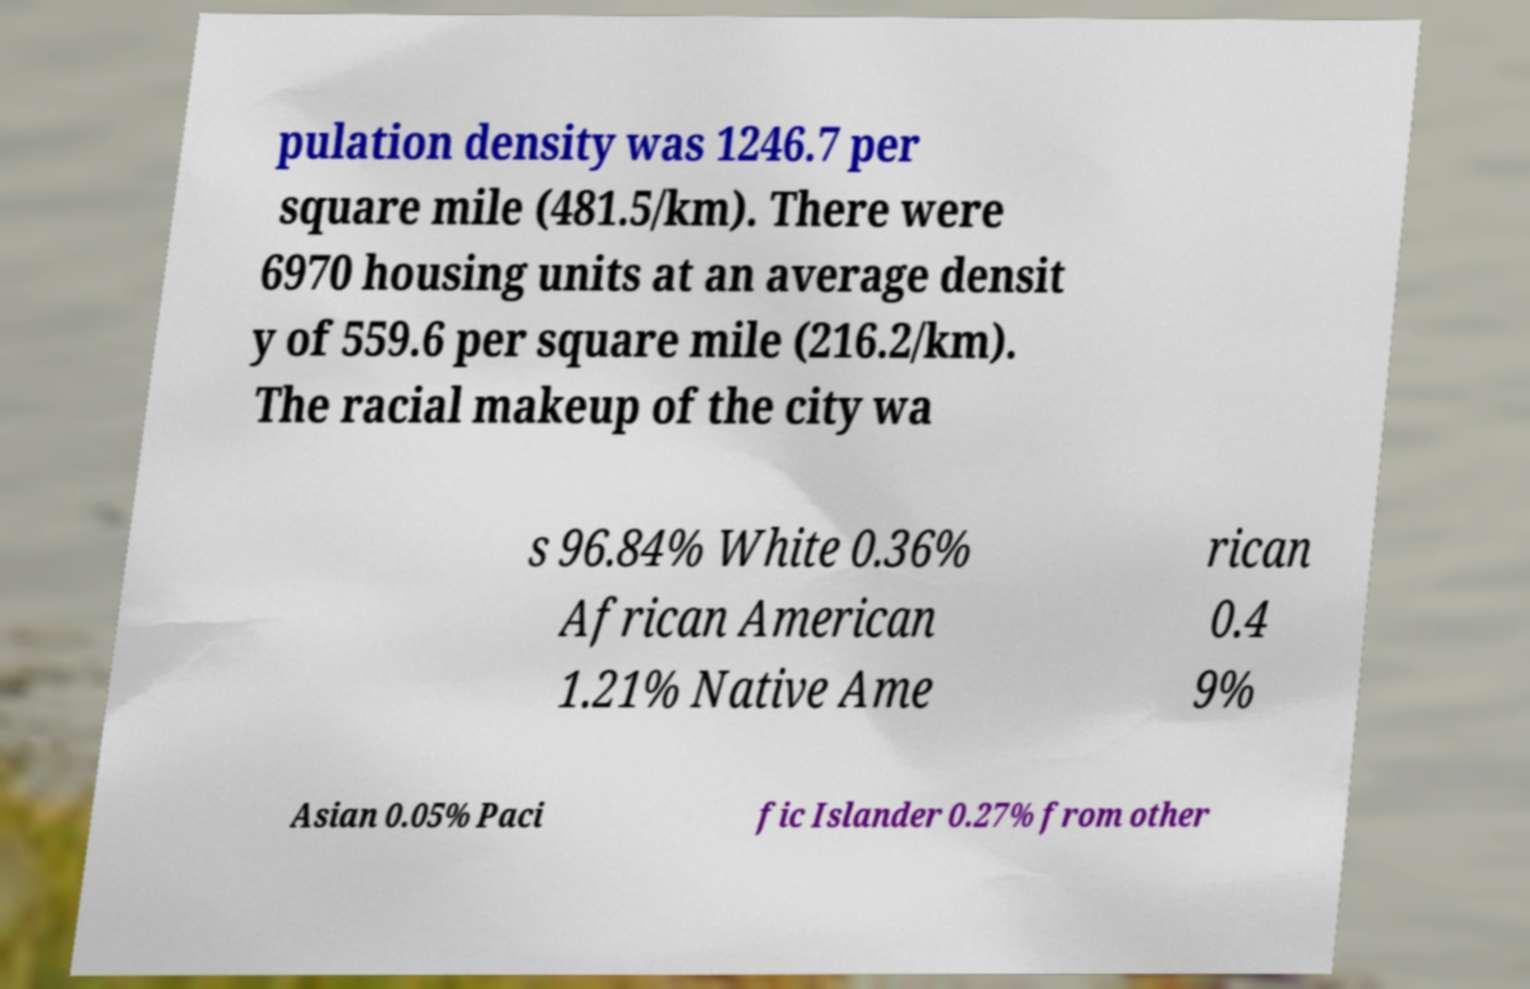Can you accurately transcribe the text from the provided image for me? pulation density was 1246.7 per square mile (481.5/km). There were 6970 housing units at an average densit y of 559.6 per square mile (216.2/km). The racial makeup of the city wa s 96.84% White 0.36% African American 1.21% Native Ame rican 0.4 9% Asian 0.05% Paci fic Islander 0.27% from other 